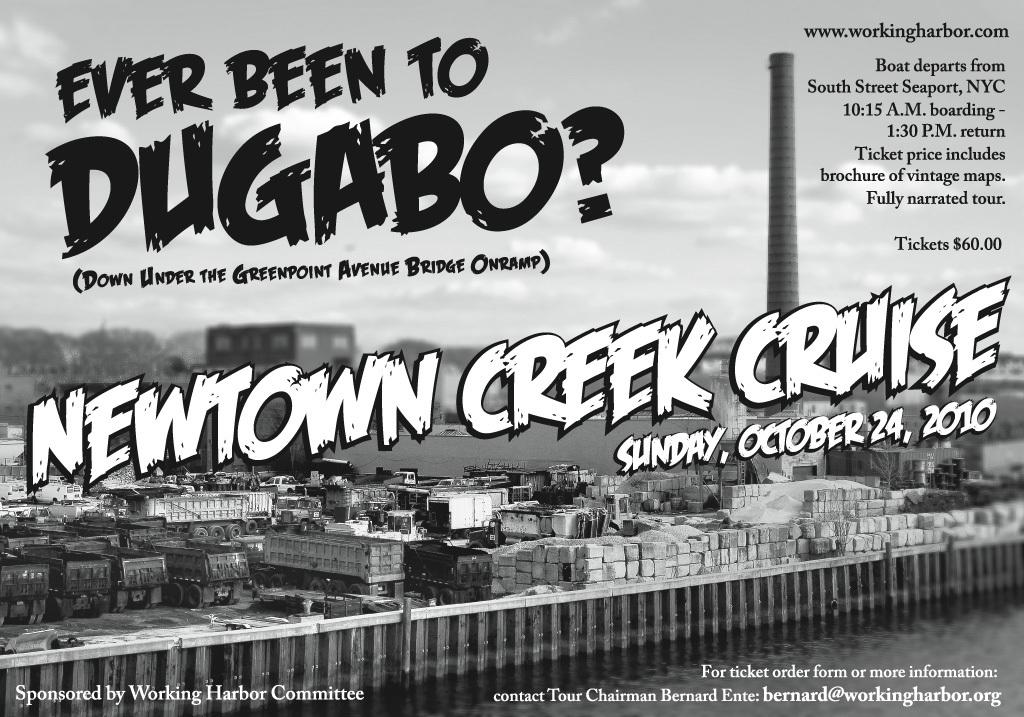<image>
Offer a succinct explanation of the picture presented. the newtown creek cruise is sunday october 24, 2010 